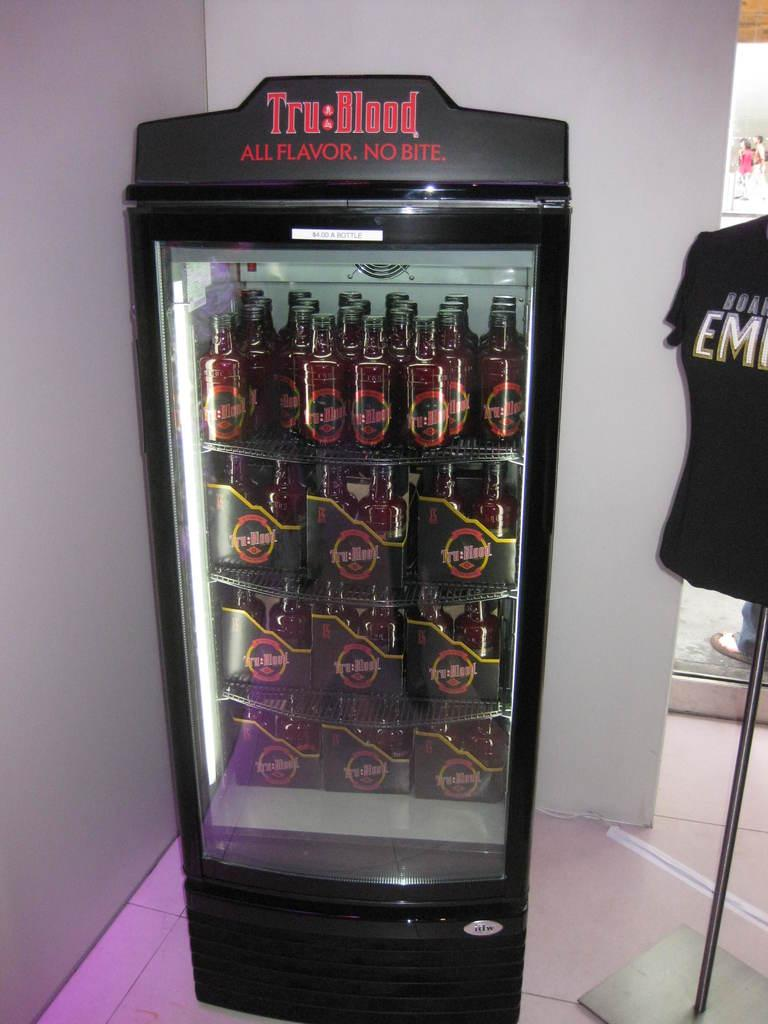<image>
Relay a brief, clear account of the picture shown. A black vending machine filled with bottles of Tru Blood. 